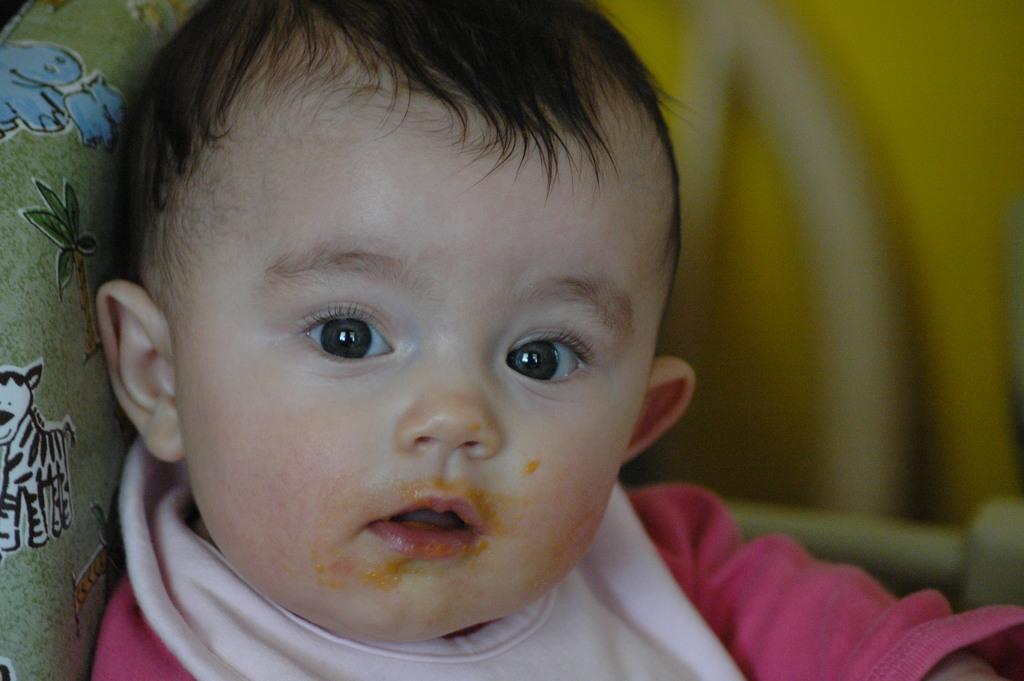Please provide a concise description of this image. In this picture I can see there is a boy sitting on the couch and he is wearing a pink shirt and there is a green pillow at left and there is a yellow on top right. 